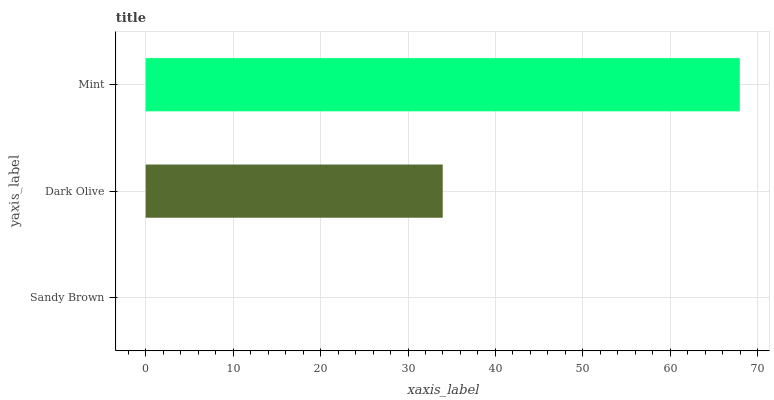Is Sandy Brown the minimum?
Answer yes or no. Yes. Is Mint the maximum?
Answer yes or no. Yes. Is Dark Olive the minimum?
Answer yes or no. No. Is Dark Olive the maximum?
Answer yes or no. No. Is Dark Olive greater than Sandy Brown?
Answer yes or no. Yes. Is Sandy Brown less than Dark Olive?
Answer yes or no. Yes. Is Sandy Brown greater than Dark Olive?
Answer yes or no. No. Is Dark Olive less than Sandy Brown?
Answer yes or no. No. Is Dark Olive the high median?
Answer yes or no. Yes. Is Dark Olive the low median?
Answer yes or no. Yes. Is Mint the high median?
Answer yes or no. No. Is Sandy Brown the low median?
Answer yes or no. No. 